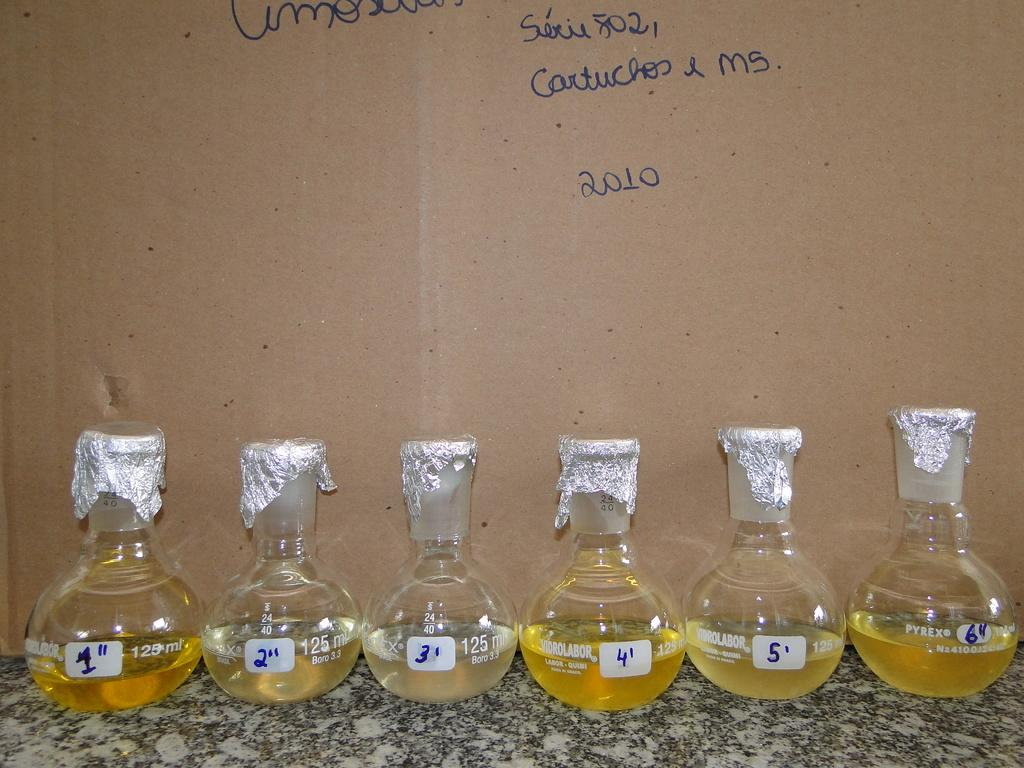How many round bottom flasks are present in the image? There are six round bottom flasks in the image. What numbers are written on the flasks? Numbers 1 to 6 are written on the flasks. What can be observed about the background of the image? There is writing on the background of the image, and it appears to have a cartoon-like appearance. How long does it take for the minute hand to complete one rotation in the image? There is no clock or minute hand present in the image, so it is not possible to answer this question. 